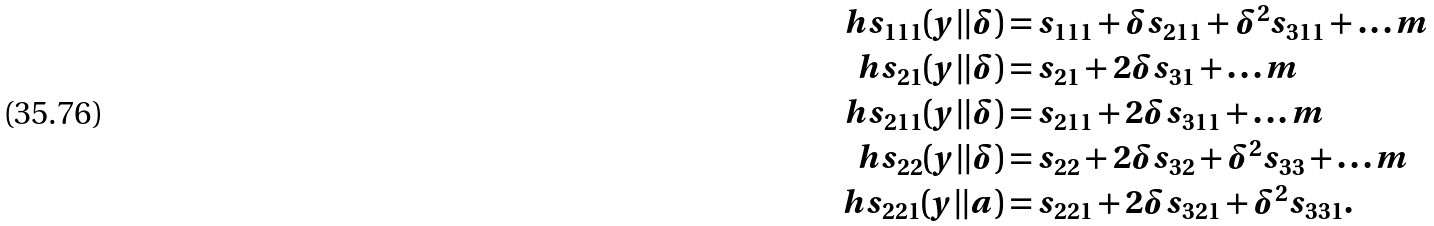<formula> <loc_0><loc_0><loc_500><loc_500>\ h s _ { 1 1 1 } ( y | | \delta ) & = s _ { 1 1 1 } + \delta s _ { 2 1 1 } + \delta ^ { 2 } s _ { 3 1 1 } + \dots m \\ \ h s _ { 2 1 } ( y | | \delta ) & = s _ { 2 1 } + 2 \delta s _ { 3 1 } + \dots m \\ \ h s _ { 2 1 1 } ( y | | \delta ) & = s _ { 2 1 1 } + 2 \delta s _ { 3 1 1 } + \dots m \\ \ h s _ { 2 2 } ( y | | \delta ) & = s _ { 2 2 } + 2 \delta s _ { 3 2 } + \delta ^ { 2 } s _ { 3 3 } + \dots m \\ \ h s _ { 2 2 1 } ( y | | a ) & = s _ { 2 2 1 } + 2 \delta s _ { 3 2 1 } + \delta ^ { 2 } s _ { 3 3 1 } .</formula> 